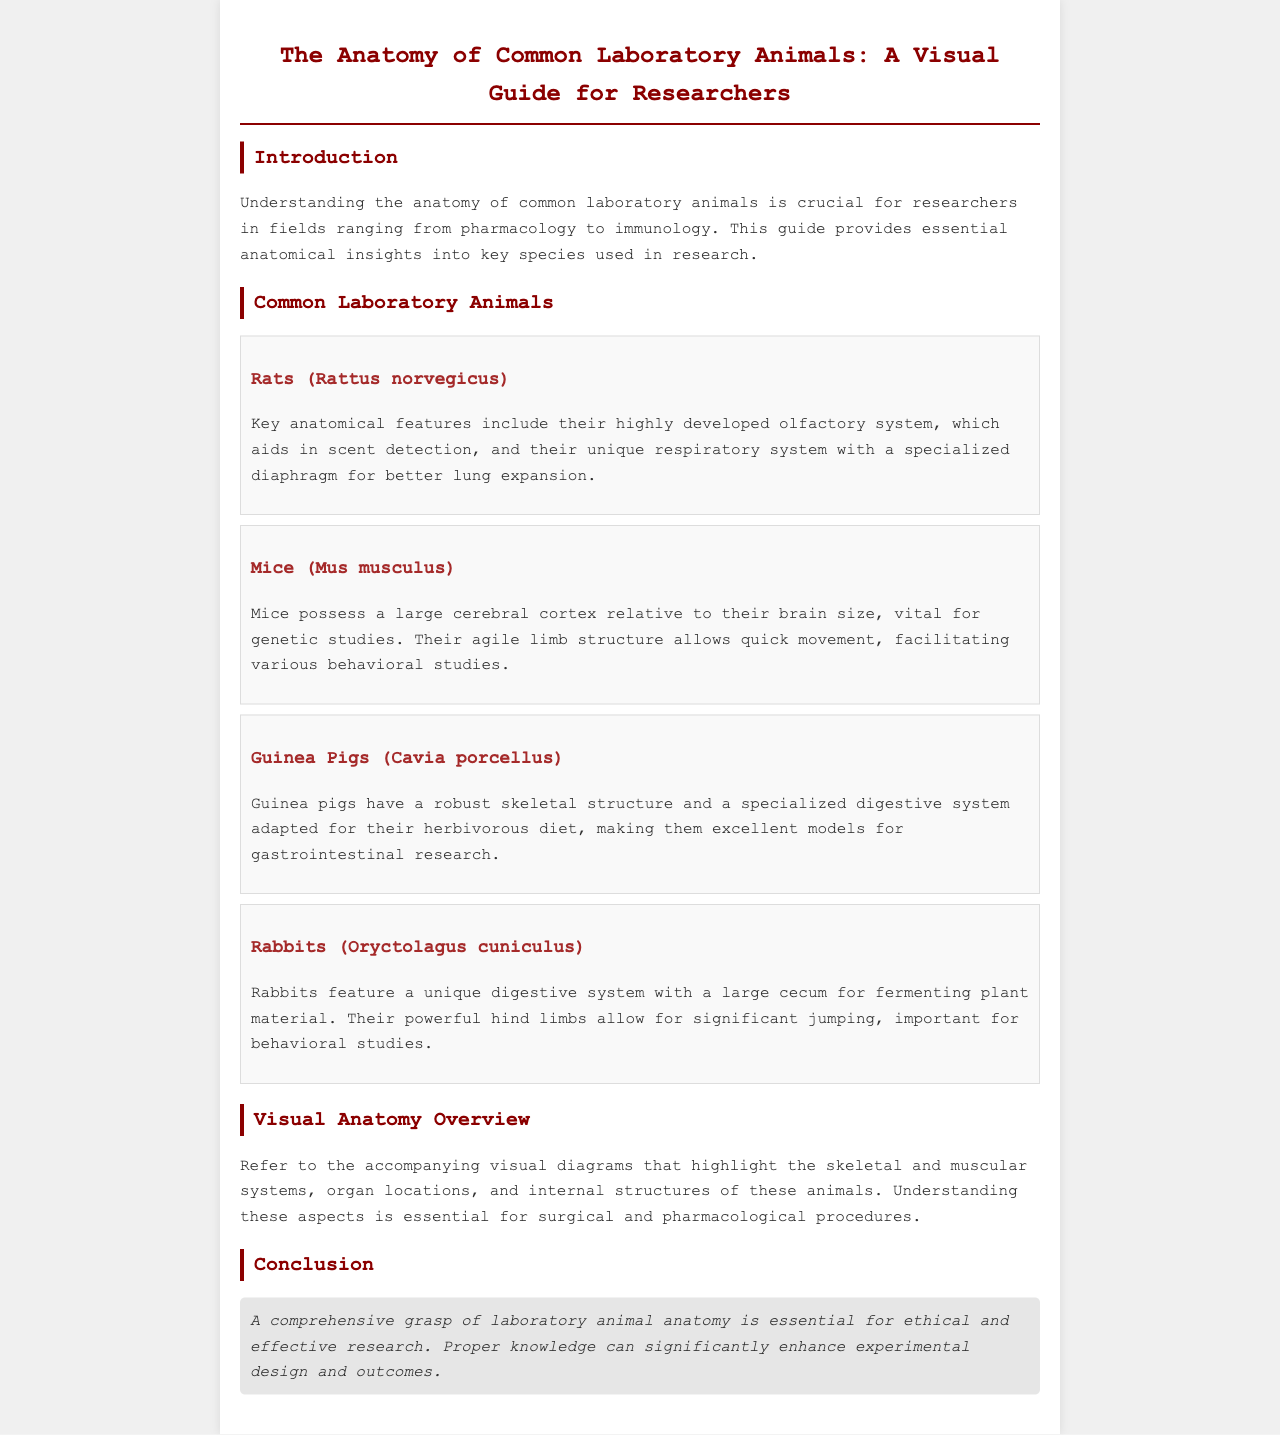what is the title of the brochure? The title is explicitly mentioned at the top of the document.
Answer: The Anatomy of Common Laboratory Animals: A Visual Guide for Researchers how many common laboratory animals are featured? The document lists four specific species of common laboratory animals.
Answer: Four which animal has a highly developed olfactory system? The document specifically mentions which animal possesses this anatomical feature.
Answer: Rats (Rattus norvegicus) what is a notable feature of the mice's brain? The text highlights a specific characteristic about the cerebral cortex in mice.
Answer: Large cerebral cortex what adaptation do guinea pigs have for their diet? The document describes a specific aspect of guinea pigs' anatomy related to their herbivorous diet.
Answer: Specialized digestive system what is mentioned about the rabbits' hind limbs? The document discusses the functionality of the hind limbs in rabbits, relating it to their movement.
Answer: Powerful hind limbs what type of research are guinea pigs excellent models for? The text states a particular area of research that guinea pigs are suited for, based on their anatomy.
Answer: Gastrointestinal research what is emphasized in the conclusion regarding research? The conclusion highlights an important aspect of understanding anatomy in relation to research.
Answer: Essential for ethical and effective research 